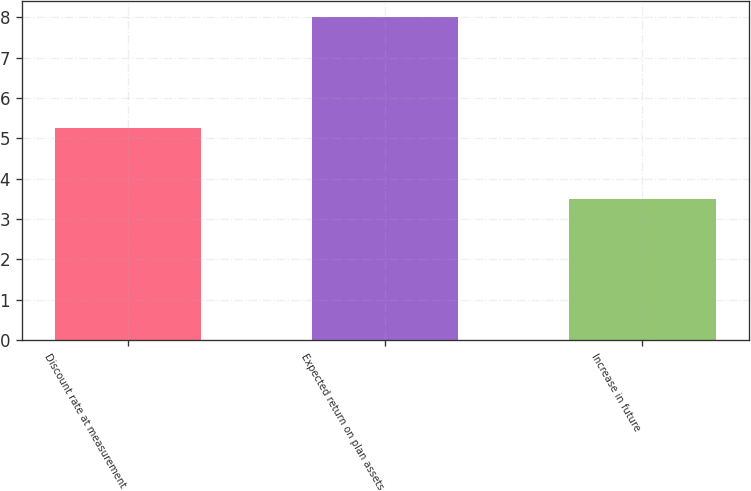<chart> <loc_0><loc_0><loc_500><loc_500><bar_chart><fcel>Discount rate at measurement<fcel>Expected return on plan assets<fcel>Increase in future<nl><fcel>5.25<fcel>8<fcel>3.5<nl></chart> 